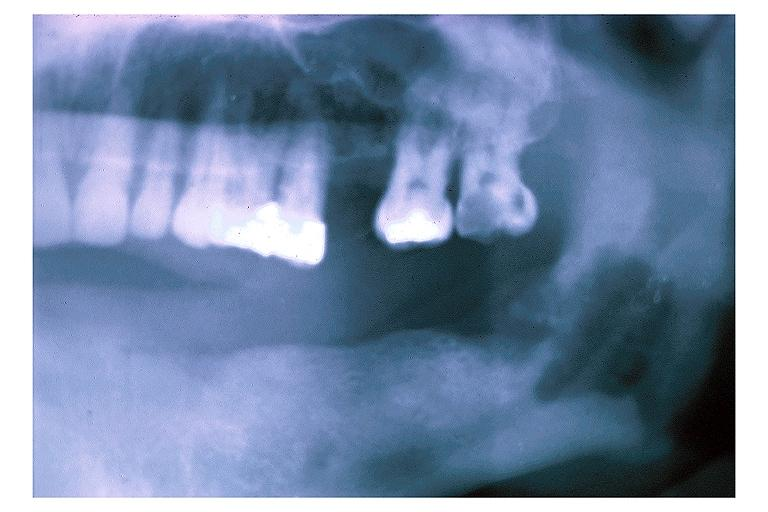does retroperitoneal liposarcoma show chronic osteomyelitis?
Answer the question using a single word or phrase. No 